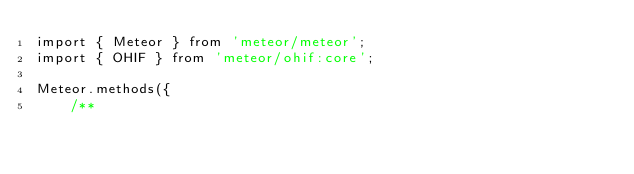<code> <loc_0><loc_0><loc_500><loc_500><_JavaScript_>import { Meteor } from 'meteor/meteor';
import { OHIF } from 'meteor/ohif:core';

Meteor.methods({
    /**</code> 